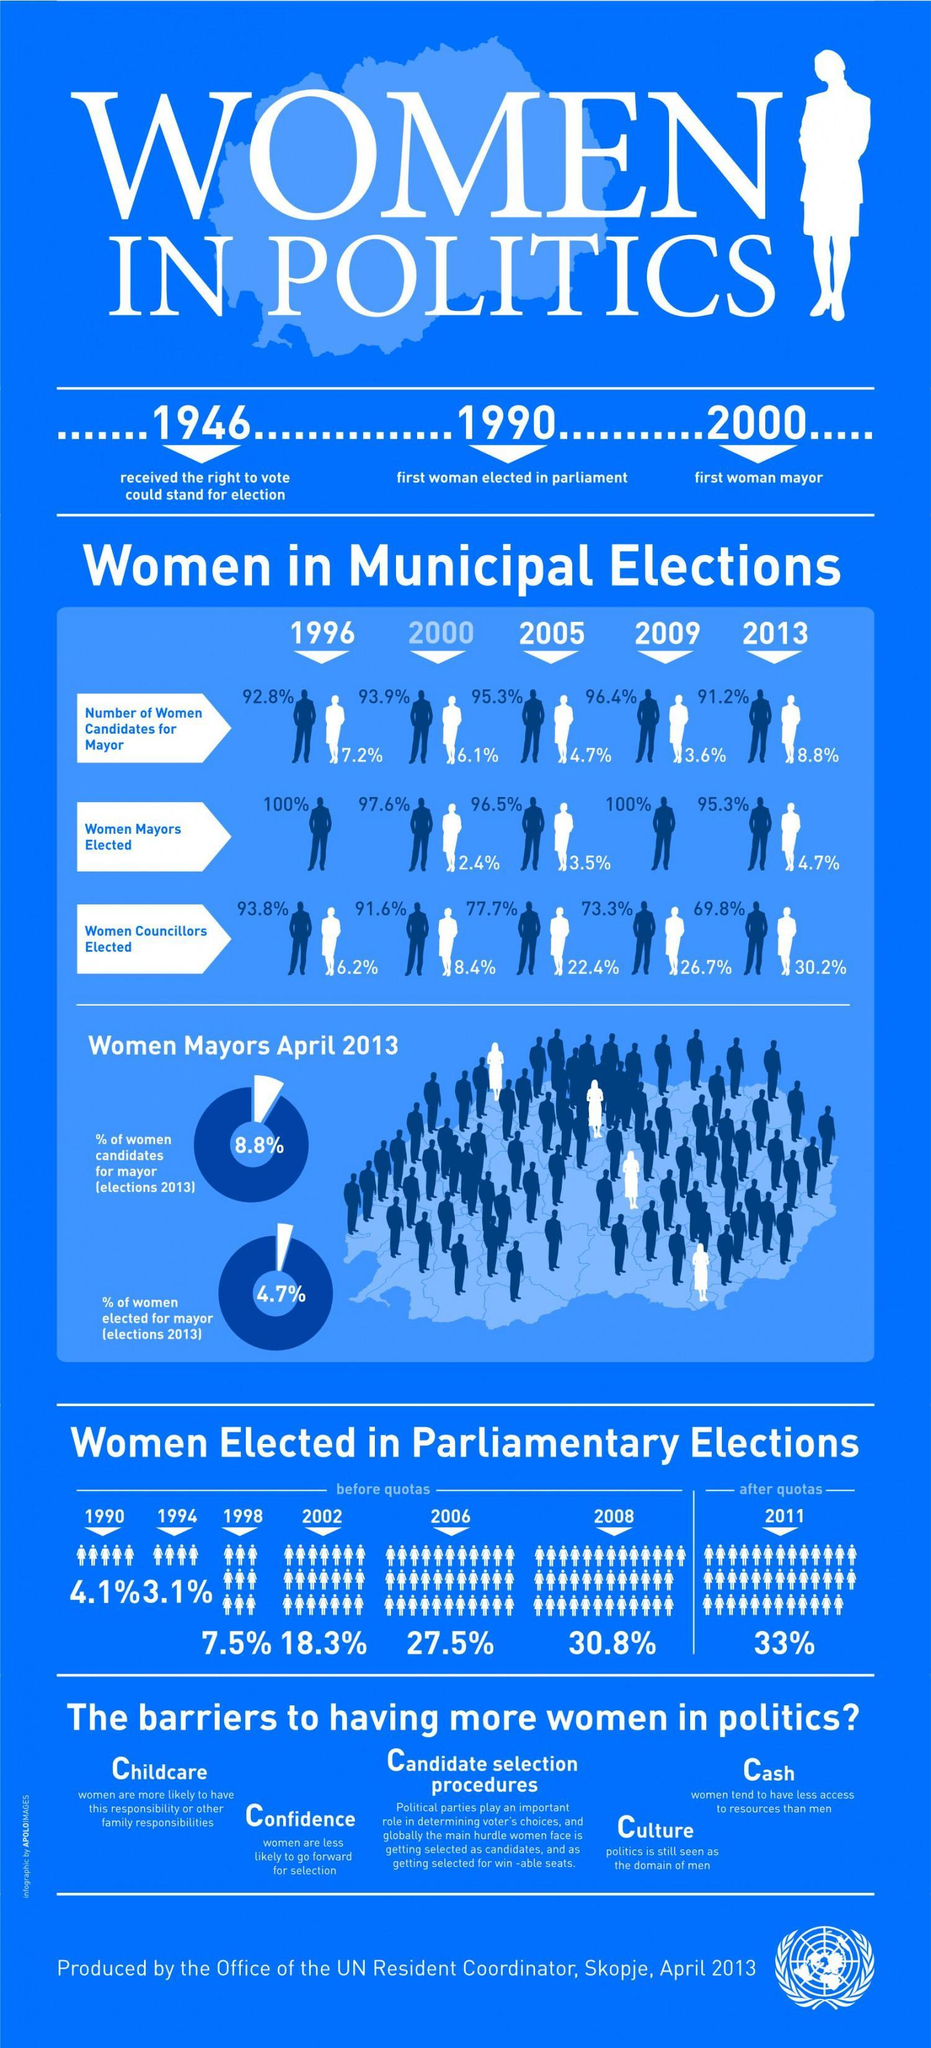What was the percent of women elected in parliament in 2008?
Answer the question with a short phrase. 30.8% In which year was the first female Mayor elected? 2000 As per the infographic, in which year was there 33% women elected in parliamentary elections? 2011 What was the percent of women elected as mayors in 2005? 3.5% What was the percentage of women candidates for mayor in the 2005 elections? 4.7% During which elections 26.7% of elected councillors were women? 2009 During which years there were no women elected as mayors? 1996, 2009 In which year did women get the right to vote? 1946 In which year was the first woman elected in parliament? 1990 What was the percentage of women councillors elected in the year 2000? 8.4% 